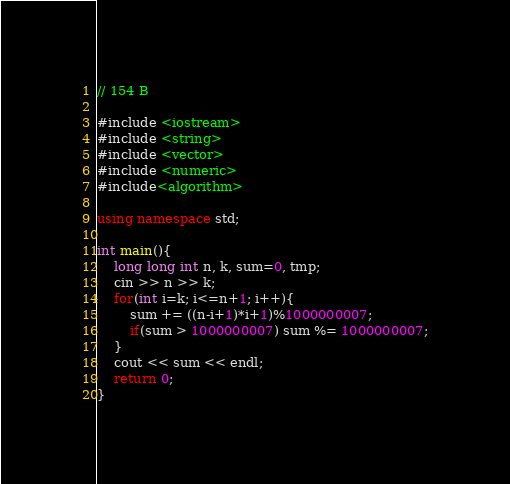Convert code to text. <code><loc_0><loc_0><loc_500><loc_500><_C++_>// 154 B

#include <iostream>
#include <string>
#include <vector>
#include <numeric>
#include<algorithm>

using namespace std;

int main(){
    long long int n, k, sum=0, tmp;
    cin >> n >> k;
    for(int i=k; i<=n+1; i++){
        sum += ((n-i+1)*i+1)%1000000007;
        if(sum > 1000000007) sum %= 1000000007;
    }
    cout << sum << endl;
    return 0;
}
</code> 